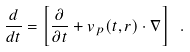Convert formula to latex. <formula><loc_0><loc_0><loc_500><loc_500>\frac { d } { d t } = \left [ \frac { \partial } { \partial t } + { v } _ { p } ( t , { r } ) \cdot \nabla \right ] \ .</formula> 